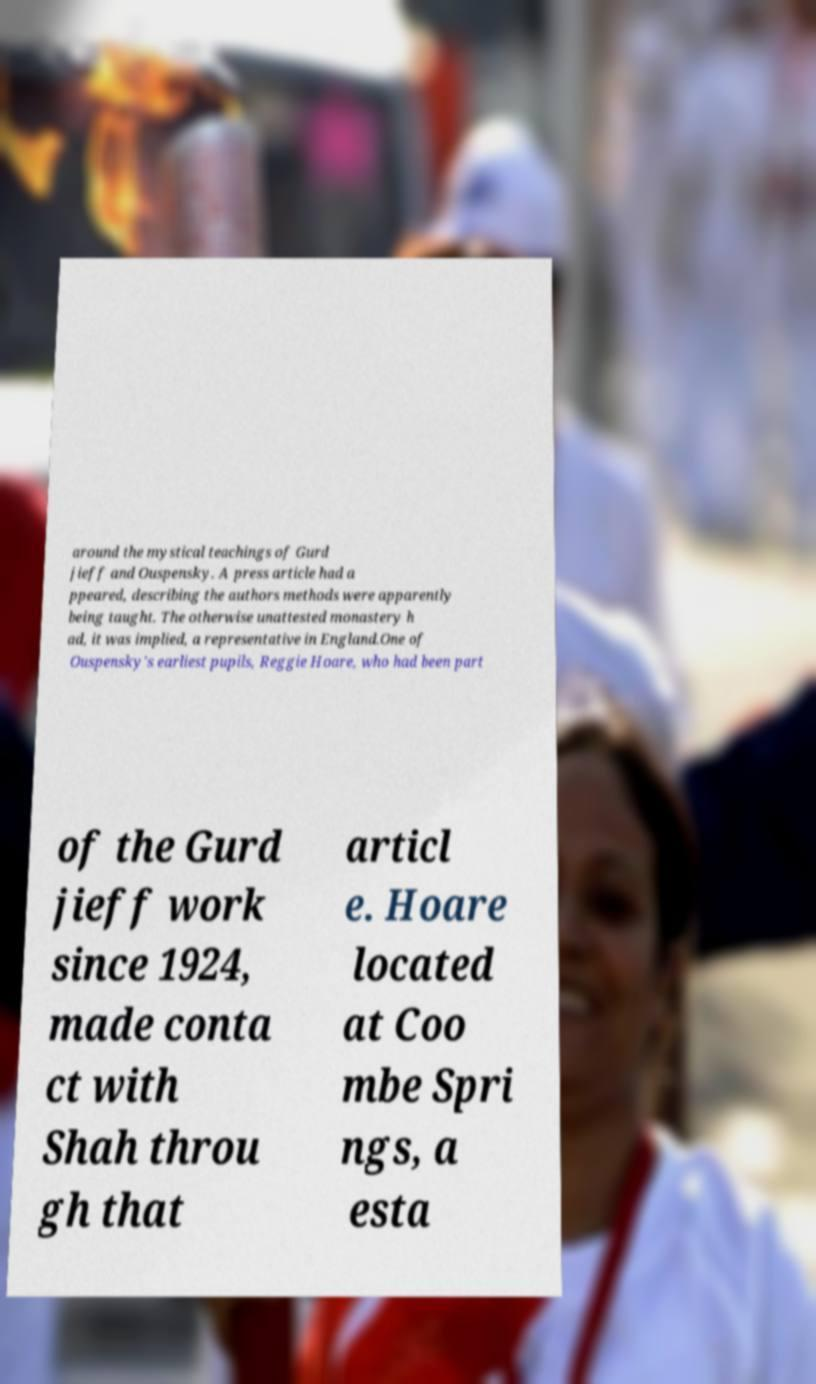Could you extract and type out the text from this image? around the mystical teachings of Gurd jieff and Ouspensky. A press article had a ppeared, describing the authors methods were apparently being taught. The otherwise unattested monastery h ad, it was implied, a representative in England.One of Ouspensky's earliest pupils, Reggie Hoare, who had been part of the Gurd jieff work since 1924, made conta ct with Shah throu gh that articl e. Hoare located at Coo mbe Spri ngs, a esta 